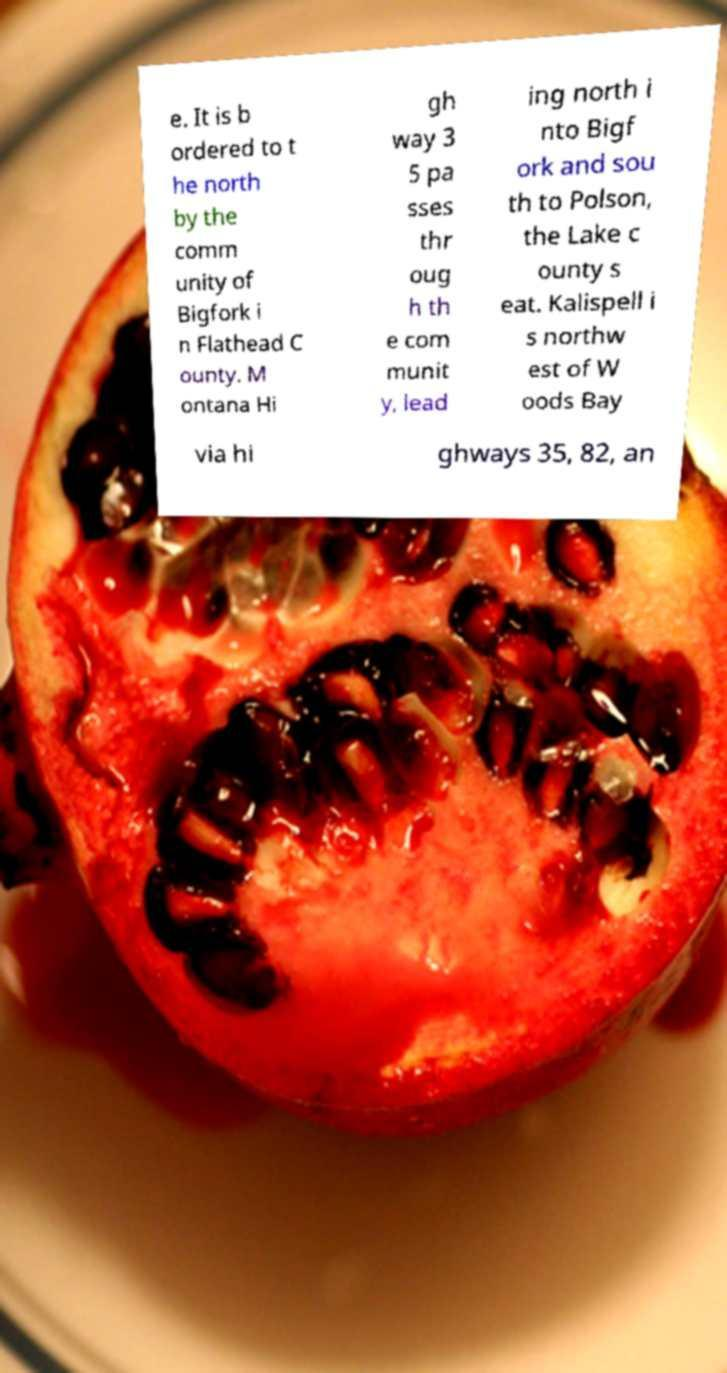Please read and relay the text visible in this image. What does it say? e. It is b ordered to t he north by the comm unity of Bigfork i n Flathead C ounty. M ontana Hi gh way 3 5 pa sses thr oug h th e com munit y, lead ing north i nto Bigf ork and sou th to Polson, the Lake c ounty s eat. Kalispell i s northw est of W oods Bay via hi ghways 35, 82, an 